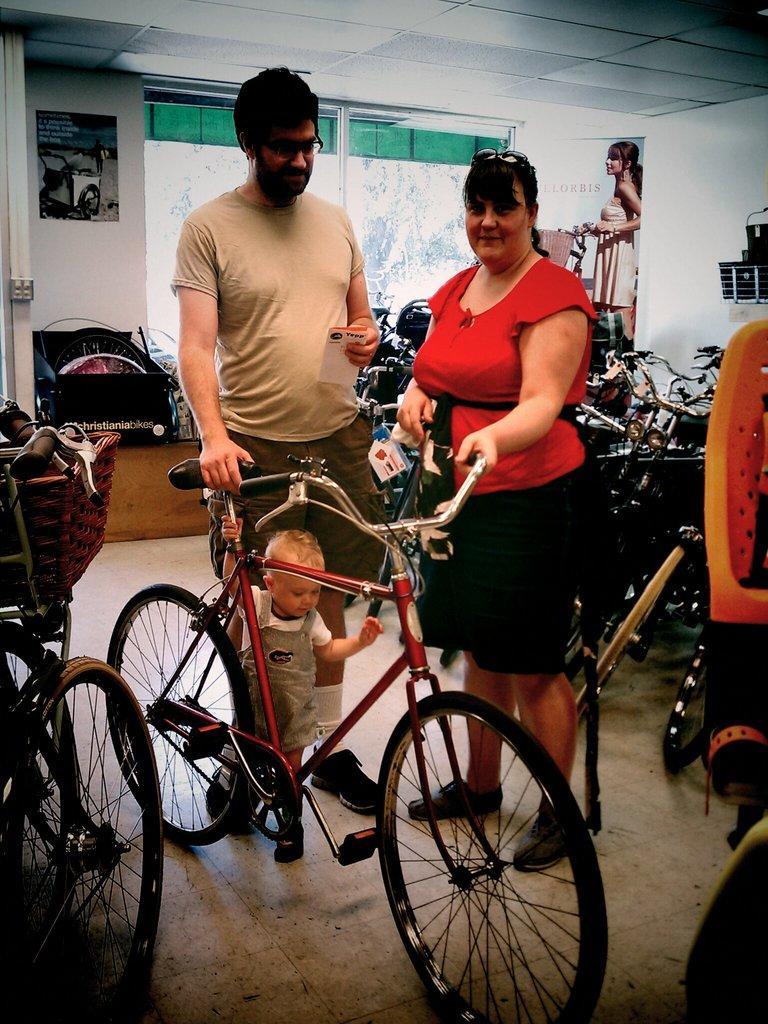Can you describe this image briefly? In this picture I can see number of cycles on the floor and in the center of this picture I can see a man, a woman and a boy who are holding a cycle. In the background I can see the wall and I see 2 posters and on the right poster, I can see a woman holding a cycle and I can see the windows. 